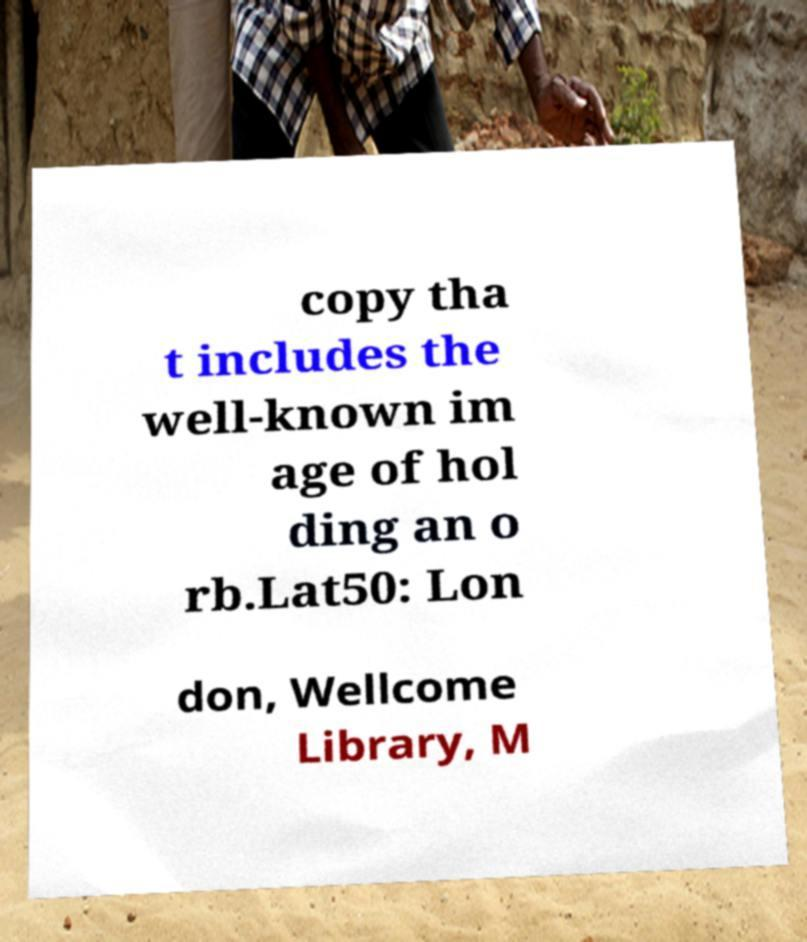Could you assist in decoding the text presented in this image and type it out clearly? copy tha t includes the well-known im age of hol ding an o rb.Lat50: Lon don, Wellcome Library, M 